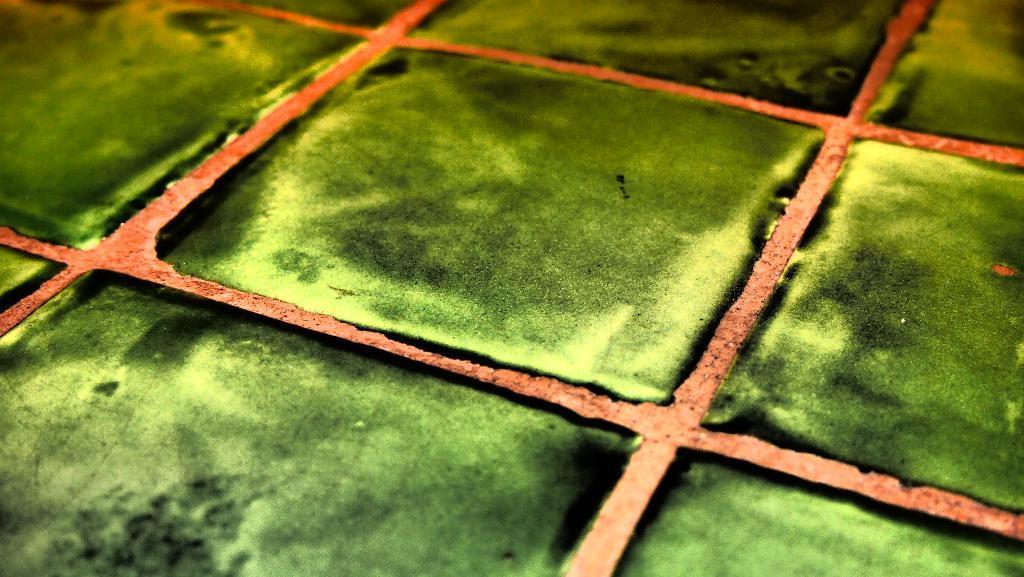How would you summarize this image in a sentence or two? In this picture I can see there is a green color floor and it has tiles. 